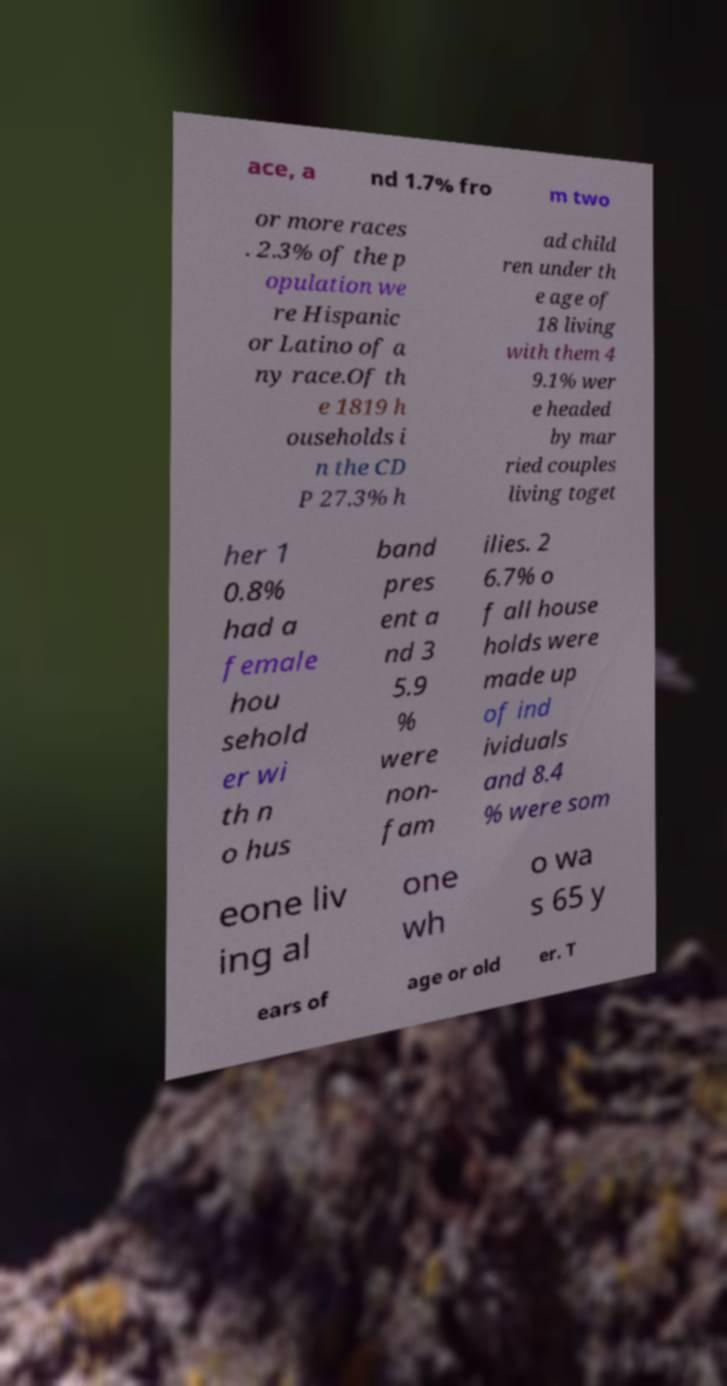Could you extract and type out the text from this image? ace, a nd 1.7% fro m two or more races . 2.3% of the p opulation we re Hispanic or Latino of a ny race.Of th e 1819 h ouseholds i n the CD P 27.3% h ad child ren under th e age of 18 living with them 4 9.1% wer e headed by mar ried couples living toget her 1 0.8% had a female hou sehold er wi th n o hus band pres ent a nd 3 5.9 % were non- fam ilies. 2 6.7% o f all house holds were made up of ind ividuals and 8.4 % were som eone liv ing al one wh o wa s 65 y ears of age or old er. T 